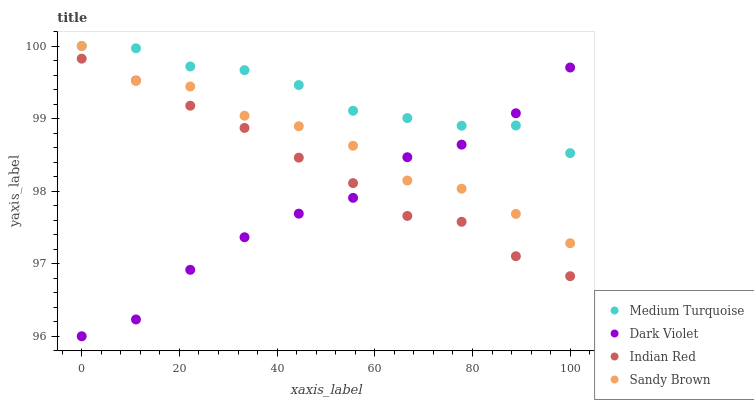Does Dark Violet have the minimum area under the curve?
Answer yes or no. Yes. Does Medium Turquoise have the maximum area under the curve?
Answer yes or no. Yes. Does Sandy Brown have the minimum area under the curve?
Answer yes or no. No. Does Sandy Brown have the maximum area under the curve?
Answer yes or no. No. Is Indian Red the smoothest?
Answer yes or no. Yes. Is Dark Violet the roughest?
Answer yes or no. Yes. Is Sandy Brown the smoothest?
Answer yes or no. No. Is Sandy Brown the roughest?
Answer yes or no. No. Does Dark Violet have the lowest value?
Answer yes or no. Yes. Does Sandy Brown have the lowest value?
Answer yes or no. No. Does Medium Turquoise have the highest value?
Answer yes or no. Yes. Does Dark Violet have the highest value?
Answer yes or no. No. Is Indian Red less than Medium Turquoise?
Answer yes or no. Yes. Is Medium Turquoise greater than Indian Red?
Answer yes or no. Yes. Does Indian Red intersect Dark Violet?
Answer yes or no. Yes. Is Indian Red less than Dark Violet?
Answer yes or no. No. Is Indian Red greater than Dark Violet?
Answer yes or no. No. Does Indian Red intersect Medium Turquoise?
Answer yes or no. No. 